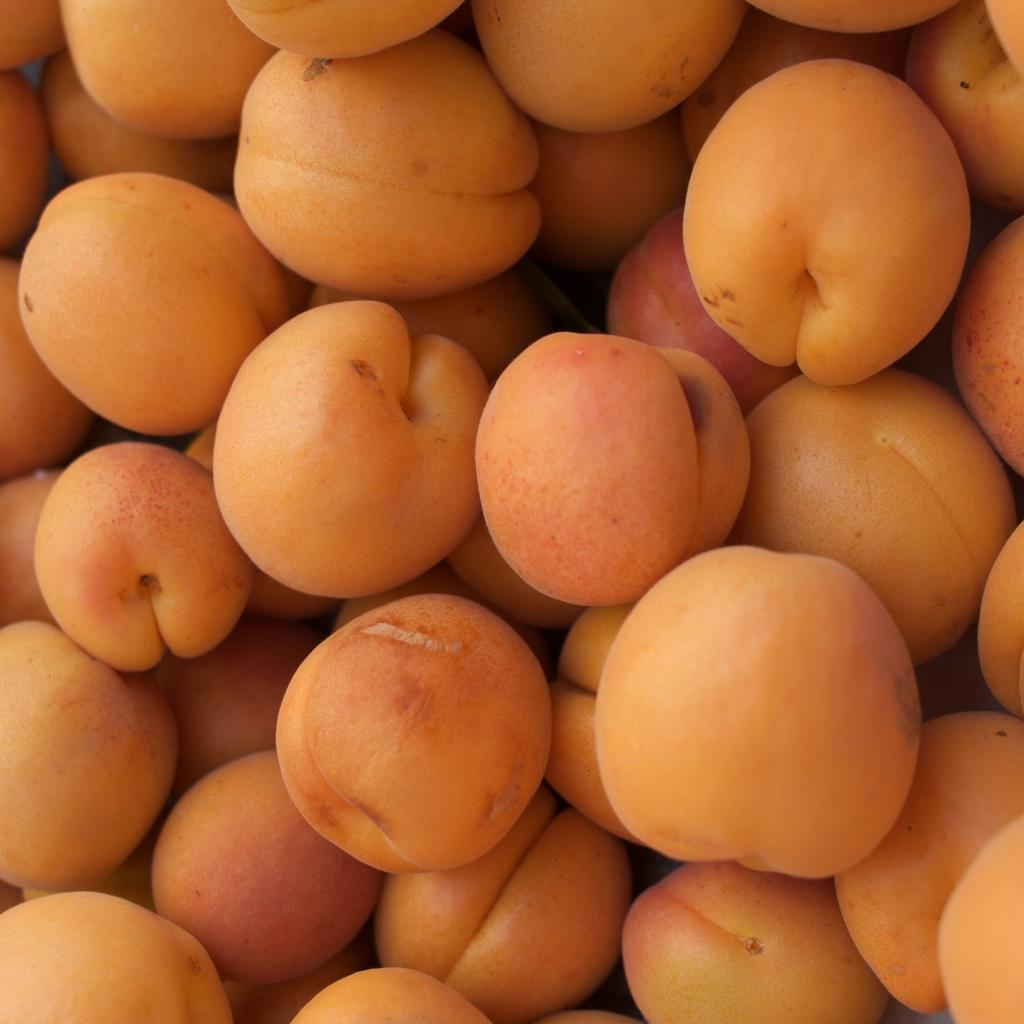What type of food can be seen in the image? There are fruits in the image. What color are the fruits in the image? The fruits are in orange color. What type of story is being told by the fruits in the image? There is no story being told by the fruits in the image; they are simply fruits of an orange color. 